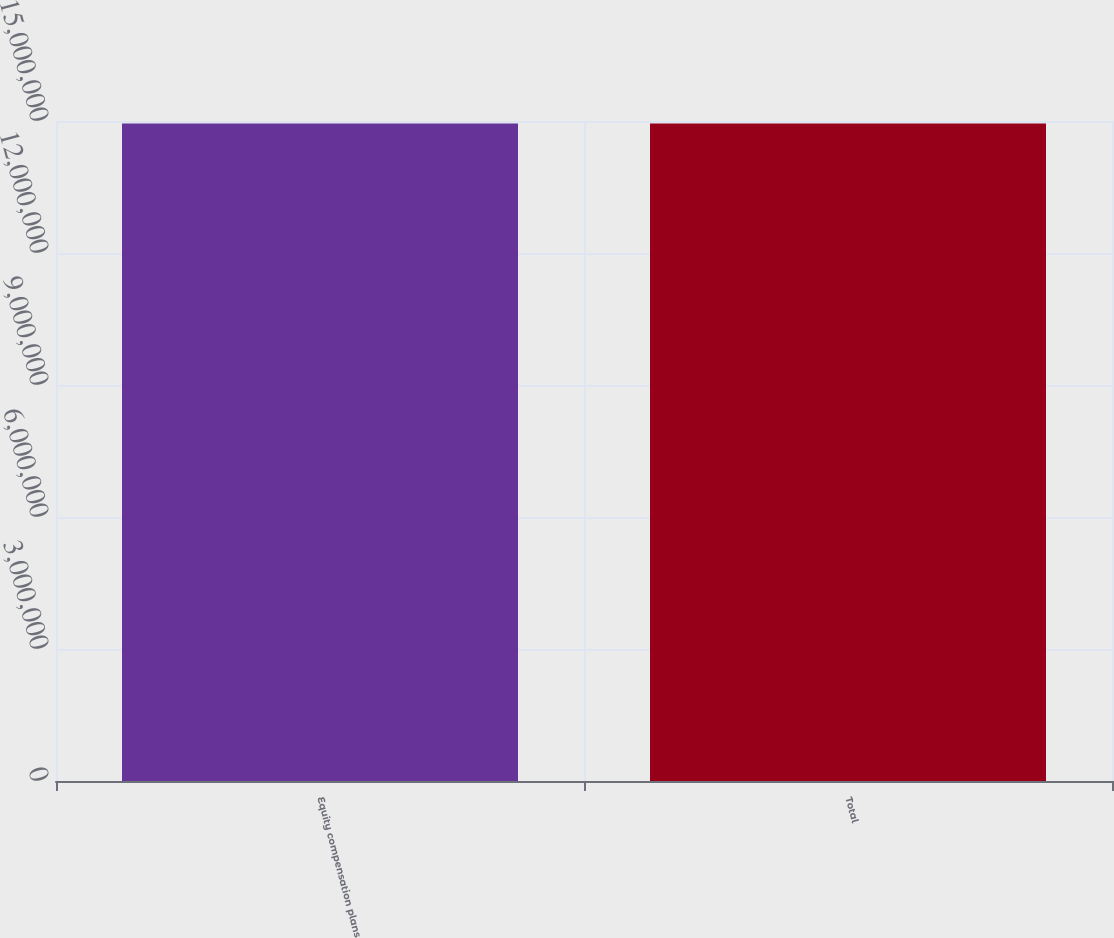Convert chart to OTSL. <chart><loc_0><loc_0><loc_500><loc_500><bar_chart><fcel>Equity compensation plans<fcel>Total<nl><fcel>1.49459e+07<fcel>1.49459e+07<nl></chart> 